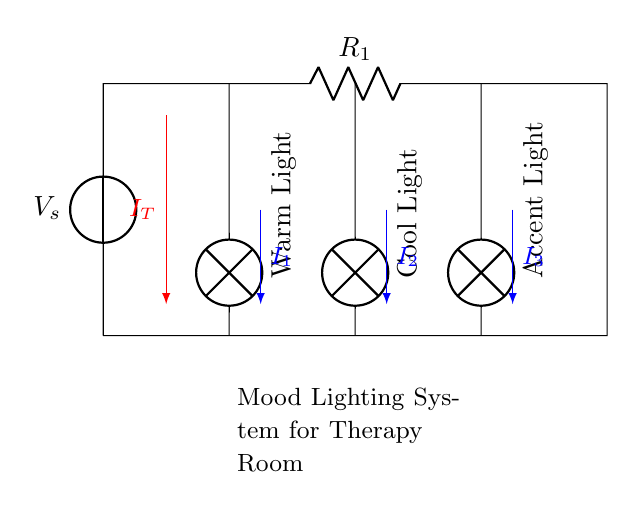What is the total current supplied in the circuit? The total current supplied, denoted as IT, is the sum of the currents through each branch of the parallel circuit. Since the exact values of the resistances are not provided, we cannot quantify it numerically, but it represents the maximum current which divides into the branches.
Answer: IT What type of circuit is depicted in the diagram? The circuit demonstrated is a parallel circuit, where multiple paths for current flow are present, allowing the lamps to operate independently. The configuration shows that all lamps are connected across the same voltage source.
Answer: Parallel How many lamps are included in the mood lighting system? The circuit diagram shows three lamps: Warm Light, Cool Light, and Accent Light. Each is connected in parallel across the total current, allowing for independent control of the lighting ambiance.
Answer: Three What is the relationship between current through each lamp and total current? In a parallel circuit, the total current divides among the branches. Each lamp gets a portion of the current proportional to its resistance. The relationship can be described mathematically by Ohm's Law and the principle of current division.
Answer: Current division Which lamp is specifically labeled as Warm Light in the circuit? The lamp labeled as Warm Light is positioned at the leftmost position in the diagram, clearly indicated with the label in a vertical orientation to signify its position in the circuit.
Answer: Warm Light What overall purpose does the lighting system serve in the therapy room? The purpose of the mood lighting system is to create a therapeutic ambiance in the room, which can positively influence the psychological state of clients during therapy sessions. The different types of lighting provide options for various emotional settings.
Answer: Therapeutic ambiance 